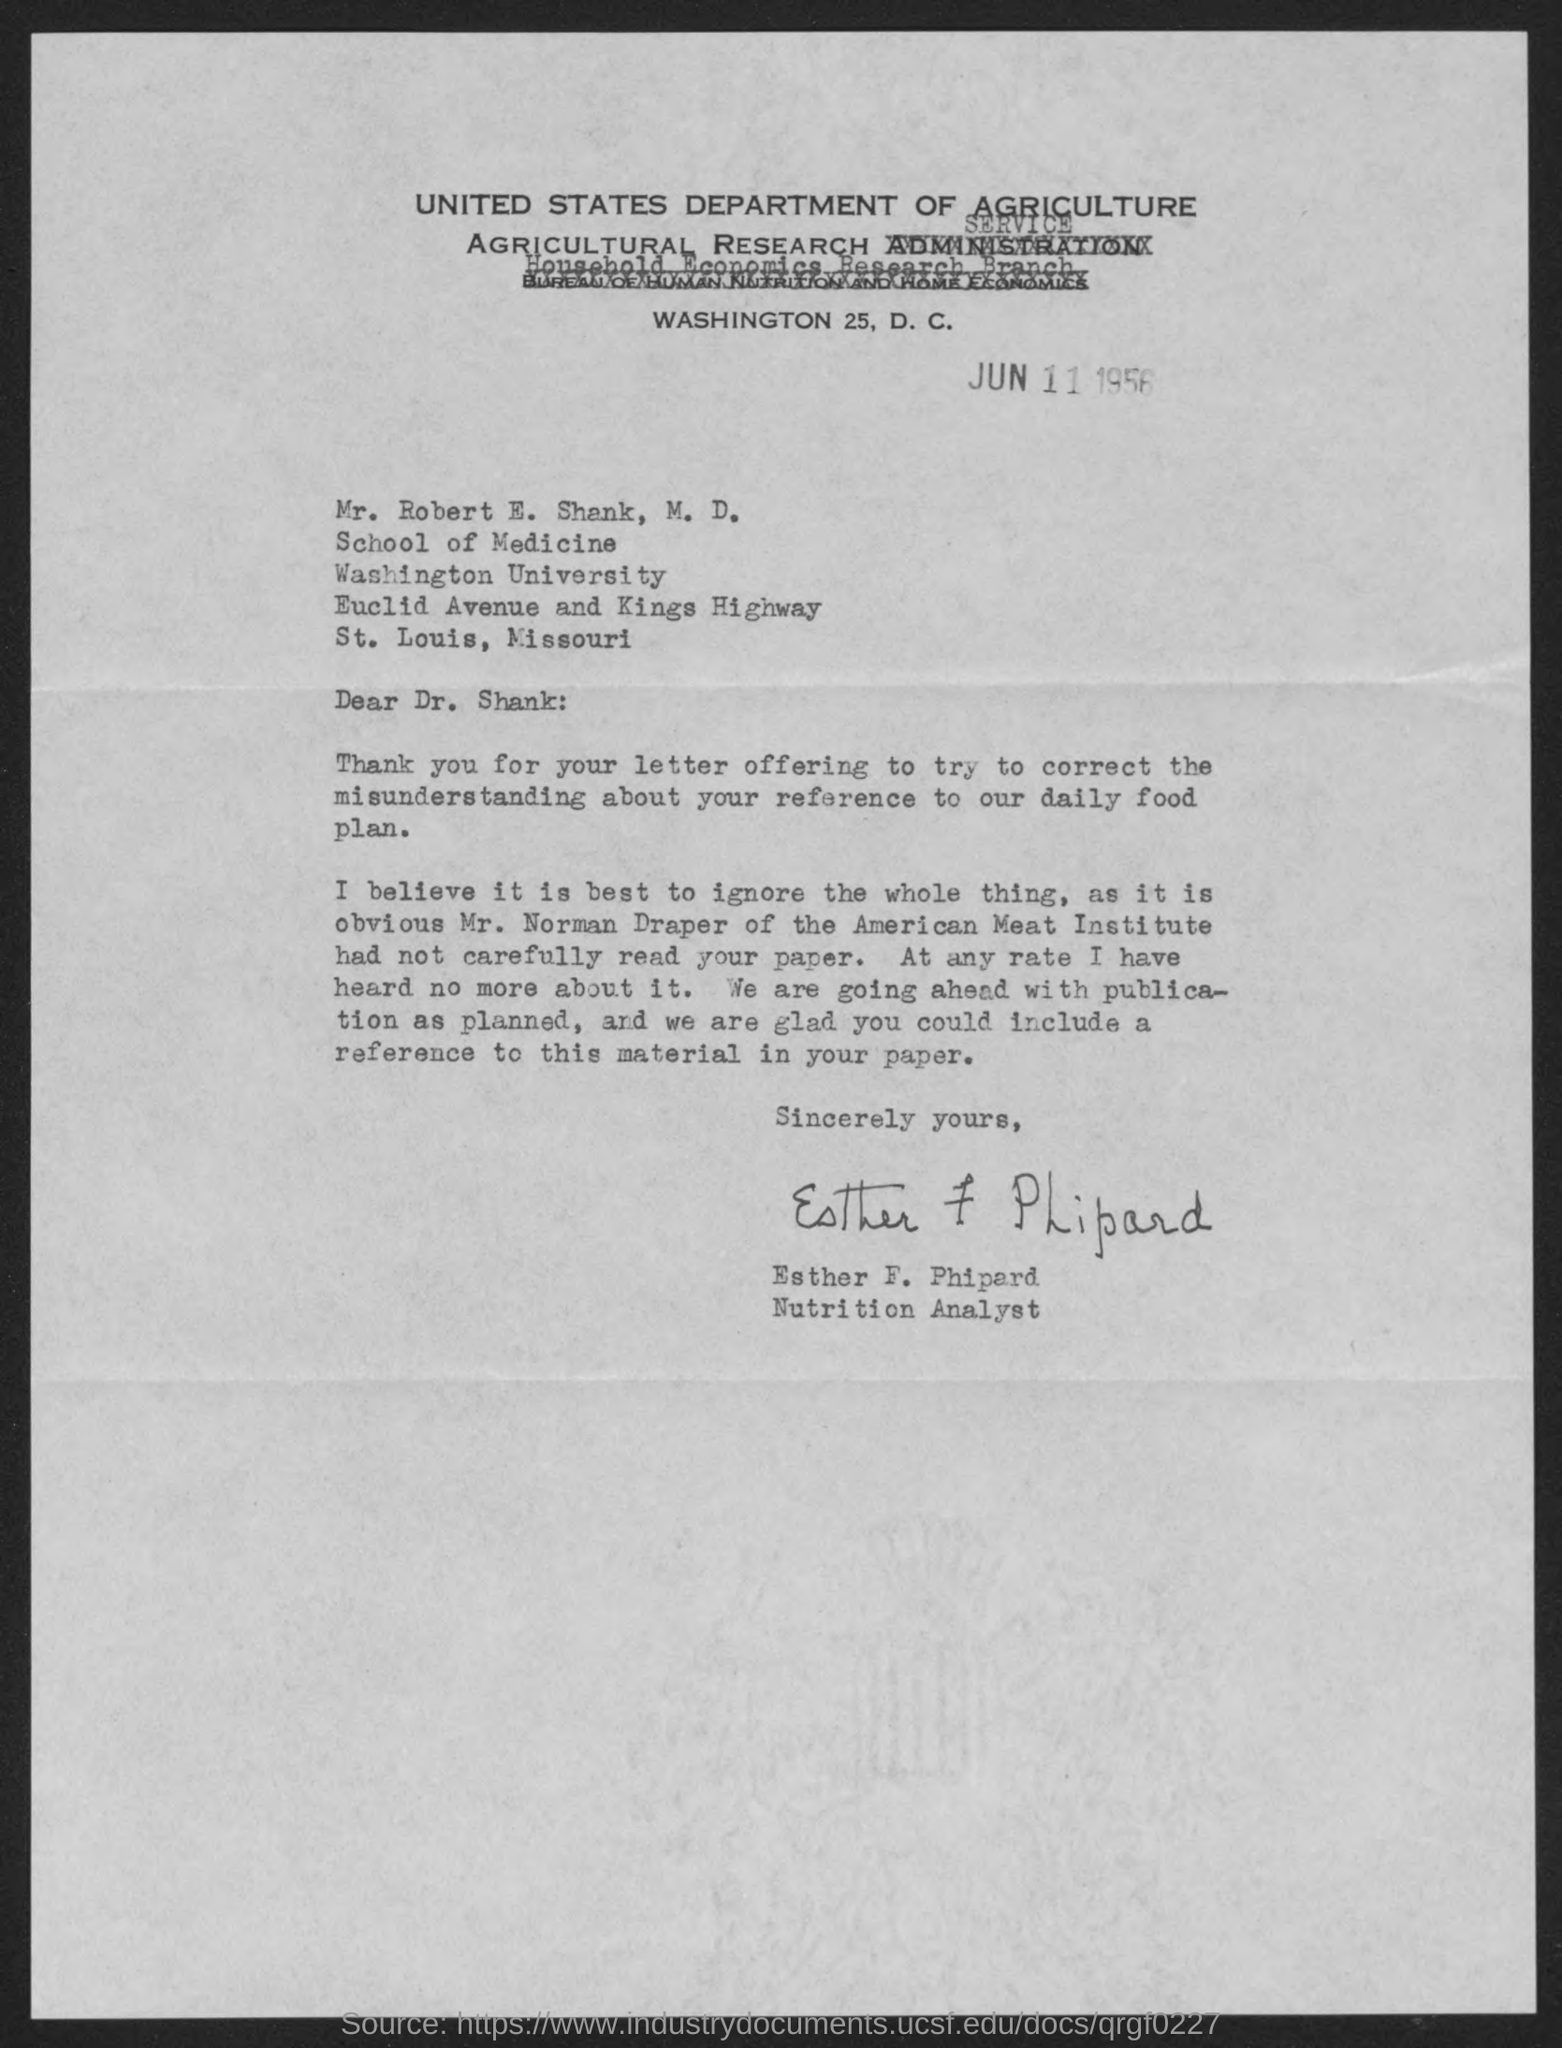When is the document dated?
Give a very brief answer. Jun 11 1956. Who has signed the letter?
Give a very brief answer. Esther F. Phipard. What is Esther's designation?
Keep it short and to the point. Nutrition Analyst. 